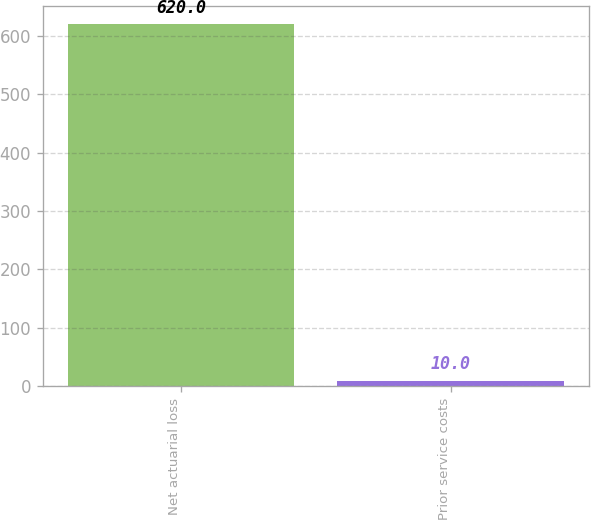Convert chart to OTSL. <chart><loc_0><loc_0><loc_500><loc_500><bar_chart><fcel>Net actuarial loss<fcel>Prior service costs<nl><fcel>620<fcel>10<nl></chart> 